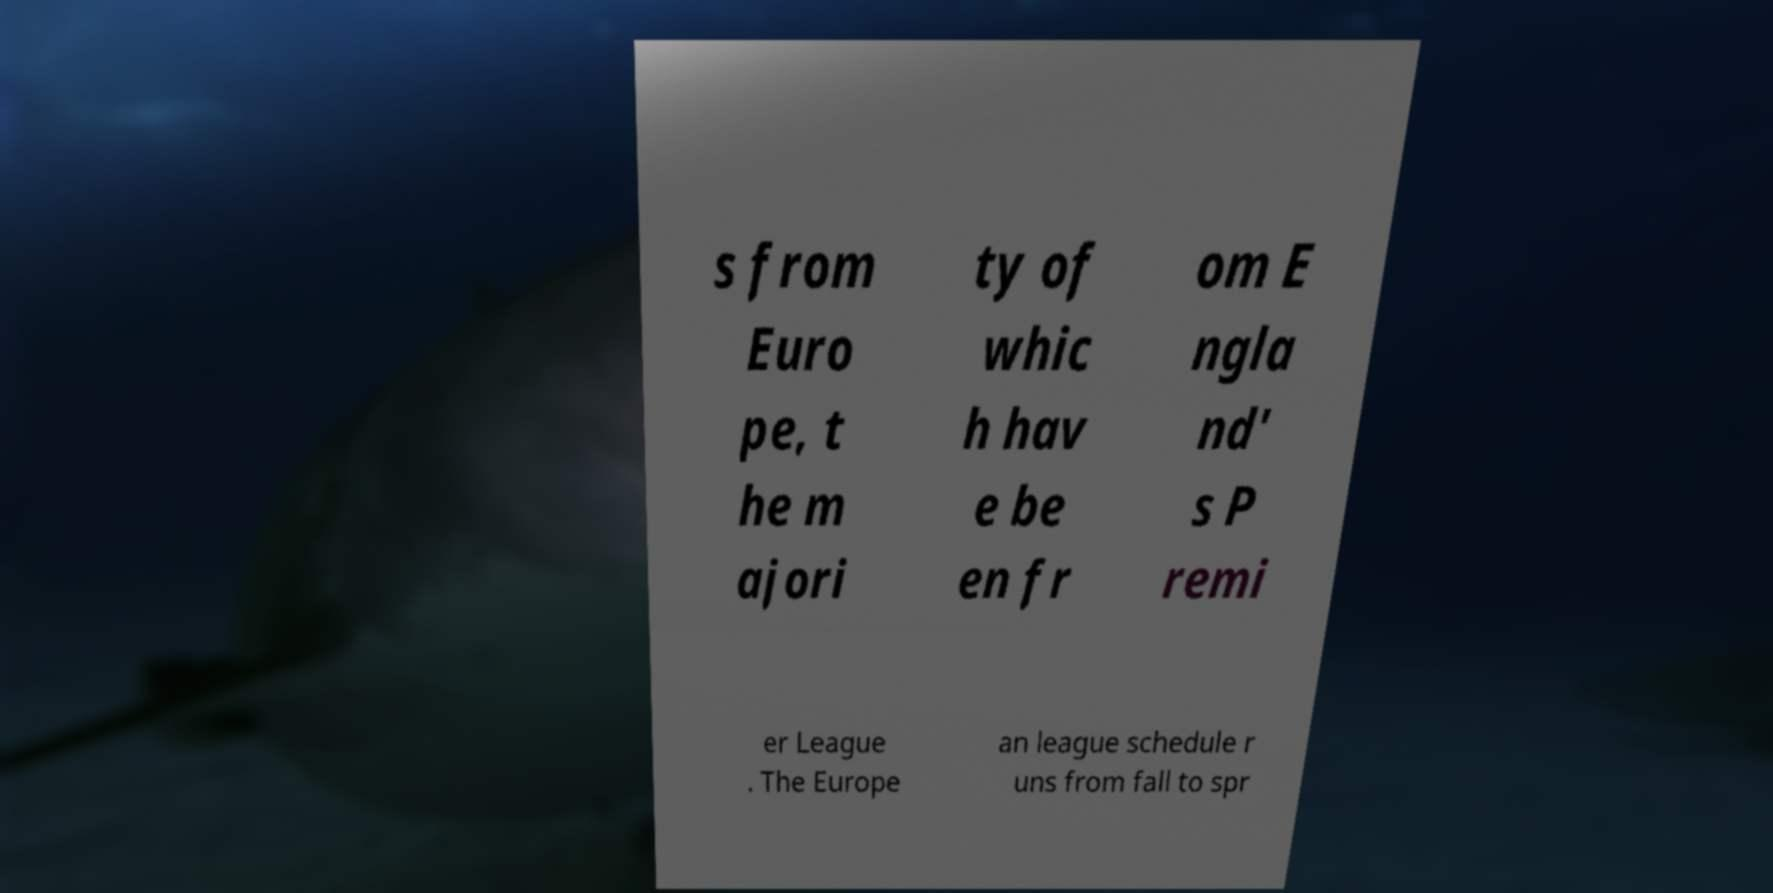There's text embedded in this image that I need extracted. Can you transcribe it verbatim? s from Euro pe, t he m ajori ty of whic h hav e be en fr om E ngla nd' s P remi er League . The Europe an league schedule r uns from fall to spr 